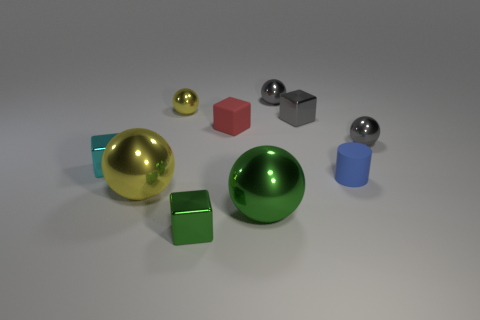Subtract all green spheres. How many spheres are left? 4 Subtract all green spheres. How many spheres are left? 4 Subtract all cyan balls. Subtract all red cubes. How many balls are left? 5 Subtract all cubes. How many objects are left? 6 Add 3 gray blocks. How many gray blocks are left? 4 Add 6 big red metallic cubes. How many big red metallic cubes exist? 6 Subtract 1 green blocks. How many objects are left? 9 Subtract all large green metallic cubes. Subtract all large yellow shiny objects. How many objects are left? 9 